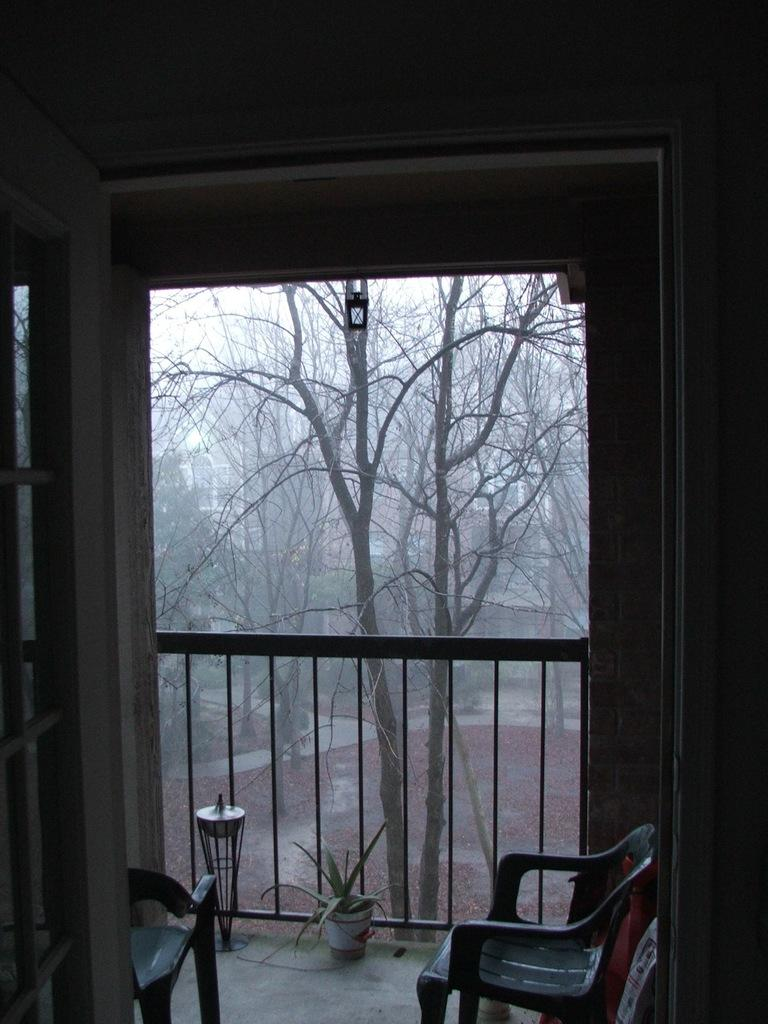How many chairs are visible in the image? There are two chairs in the image. What can be seen in the background of the image? There is a fence, a flower pot with a plant, trees, and a wall in the image. What type of box is being used to store the flowers in the image? There is no box present in the image; the flowers are in a flower pot. 